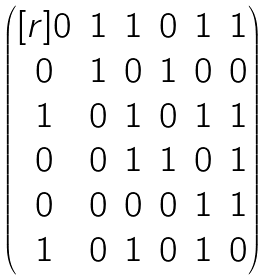<formula> <loc_0><loc_0><loc_500><loc_500>\begin{pmatrix} [ r ] 0 & 1 & 1 & 0 & 1 & 1 \\ 0 & 1 & 0 & 1 & 0 & 0 \\ 1 & 0 & 1 & 0 & 1 & 1 \\ 0 & 0 & 1 & 1 & 0 & 1 \\ 0 & 0 & 0 & 0 & 1 & 1 \\ 1 & 0 & 1 & 0 & 1 & 0 \end{pmatrix}</formula> 